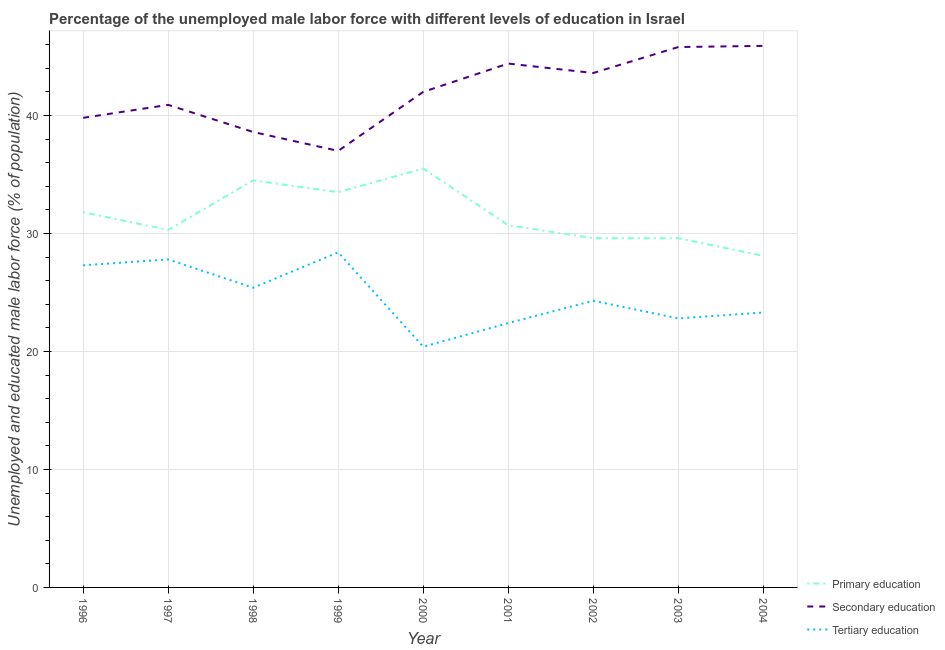How many different coloured lines are there?
Provide a succinct answer. 3. What is the percentage of male labor force who received tertiary education in 2003?
Ensure brevity in your answer.  22.8. Across all years, what is the maximum percentage of male labor force who received primary education?
Ensure brevity in your answer.  35.5. Across all years, what is the minimum percentage of male labor force who received primary education?
Your answer should be compact. 28.1. In which year was the percentage of male labor force who received tertiary education minimum?
Give a very brief answer. 2000. What is the total percentage of male labor force who received secondary education in the graph?
Offer a very short reply. 378. What is the difference between the percentage of male labor force who received secondary education in 1996 and that in 2000?
Your answer should be very brief. -2.2. What is the difference between the percentage of male labor force who received primary education in 2001 and the percentage of male labor force who received secondary education in 2003?
Give a very brief answer. -15.1. What is the average percentage of male labor force who received secondary education per year?
Ensure brevity in your answer.  42. In the year 2003, what is the difference between the percentage of male labor force who received secondary education and percentage of male labor force who received tertiary education?
Provide a short and direct response. 23. What is the ratio of the percentage of male labor force who received tertiary education in 1998 to that in 1999?
Ensure brevity in your answer.  0.89. Is the percentage of male labor force who received tertiary education in 1998 less than that in 2000?
Your response must be concise. No. What is the difference between the highest and the second highest percentage of male labor force who received secondary education?
Your answer should be compact. 0.1. What is the difference between the highest and the lowest percentage of male labor force who received primary education?
Offer a terse response. 7.4. Is the sum of the percentage of male labor force who received primary education in 2000 and 2001 greater than the maximum percentage of male labor force who received tertiary education across all years?
Keep it short and to the point. Yes. Is the percentage of male labor force who received primary education strictly less than the percentage of male labor force who received tertiary education over the years?
Offer a very short reply. No. Are the values on the major ticks of Y-axis written in scientific E-notation?
Provide a short and direct response. No. Does the graph contain any zero values?
Your answer should be very brief. No. Where does the legend appear in the graph?
Your answer should be compact. Bottom right. What is the title of the graph?
Ensure brevity in your answer.  Percentage of the unemployed male labor force with different levels of education in Israel. What is the label or title of the Y-axis?
Give a very brief answer. Unemployed and educated male labor force (% of population). What is the Unemployed and educated male labor force (% of population) in Primary education in 1996?
Your answer should be very brief. 31.8. What is the Unemployed and educated male labor force (% of population) in Secondary education in 1996?
Provide a succinct answer. 39.8. What is the Unemployed and educated male labor force (% of population) in Tertiary education in 1996?
Your answer should be very brief. 27.3. What is the Unemployed and educated male labor force (% of population) in Primary education in 1997?
Provide a short and direct response. 30.3. What is the Unemployed and educated male labor force (% of population) of Secondary education in 1997?
Your answer should be compact. 40.9. What is the Unemployed and educated male labor force (% of population) of Tertiary education in 1997?
Make the answer very short. 27.8. What is the Unemployed and educated male labor force (% of population) of Primary education in 1998?
Keep it short and to the point. 34.5. What is the Unemployed and educated male labor force (% of population) in Secondary education in 1998?
Your answer should be compact. 38.6. What is the Unemployed and educated male labor force (% of population) in Tertiary education in 1998?
Offer a terse response. 25.4. What is the Unemployed and educated male labor force (% of population) of Primary education in 1999?
Ensure brevity in your answer.  33.5. What is the Unemployed and educated male labor force (% of population) of Secondary education in 1999?
Provide a succinct answer. 37. What is the Unemployed and educated male labor force (% of population) in Tertiary education in 1999?
Your response must be concise. 28.4. What is the Unemployed and educated male labor force (% of population) of Primary education in 2000?
Provide a succinct answer. 35.5. What is the Unemployed and educated male labor force (% of population) of Tertiary education in 2000?
Offer a very short reply. 20.4. What is the Unemployed and educated male labor force (% of population) in Primary education in 2001?
Your answer should be very brief. 30.7. What is the Unemployed and educated male labor force (% of population) of Secondary education in 2001?
Offer a terse response. 44.4. What is the Unemployed and educated male labor force (% of population) in Tertiary education in 2001?
Give a very brief answer. 22.4. What is the Unemployed and educated male labor force (% of population) in Primary education in 2002?
Ensure brevity in your answer.  29.6. What is the Unemployed and educated male labor force (% of population) in Secondary education in 2002?
Your response must be concise. 43.6. What is the Unemployed and educated male labor force (% of population) of Tertiary education in 2002?
Ensure brevity in your answer.  24.3. What is the Unemployed and educated male labor force (% of population) in Primary education in 2003?
Keep it short and to the point. 29.6. What is the Unemployed and educated male labor force (% of population) in Secondary education in 2003?
Offer a terse response. 45.8. What is the Unemployed and educated male labor force (% of population) in Tertiary education in 2003?
Provide a short and direct response. 22.8. What is the Unemployed and educated male labor force (% of population) in Primary education in 2004?
Your response must be concise. 28.1. What is the Unemployed and educated male labor force (% of population) of Secondary education in 2004?
Offer a very short reply. 45.9. What is the Unemployed and educated male labor force (% of population) of Tertiary education in 2004?
Offer a terse response. 23.3. Across all years, what is the maximum Unemployed and educated male labor force (% of population) in Primary education?
Keep it short and to the point. 35.5. Across all years, what is the maximum Unemployed and educated male labor force (% of population) of Secondary education?
Ensure brevity in your answer.  45.9. Across all years, what is the maximum Unemployed and educated male labor force (% of population) in Tertiary education?
Offer a terse response. 28.4. Across all years, what is the minimum Unemployed and educated male labor force (% of population) of Primary education?
Offer a very short reply. 28.1. Across all years, what is the minimum Unemployed and educated male labor force (% of population) of Secondary education?
Offer a terse response. 37. Across all years, what is the minimum Unemployed and educated male labor force (% of population) of Tertiary education?
Offer a very short reply. 20.4. What is the total Unemployed and educated male labor force (% of population) of Primary education in the graph?
Offer a very short reply. 283.6. What is the total Unemployed and educated male labor force (% of population) of Secondary education in the graph?
Give a very brief answer. 378. What is the total Unemployed and educated male labor force (% of population) of Tertiary education in the graph?
Provide a short and direct response. 222.1. What is the difference between the Unemployed and educated male labor force (% of population) in Primary education in 1996 and that in 1997?
Ensure brevity in your answer.  1.5. What is the difference between the Unemployed and educated male labor force (% of population) of Tertiary education in 1996 and that in 1997?
Keep it short and to the point. -0.5. What is the difference between the Unemployed and educated male labor force (% of population) in Primary education in 1996 and that in 1998?
Provide a succinct answer. -2.7. What is the difference between the Unemployed and educated male labor force (% of population) in Secondary education in 1996 and that in 1998?
Offer a terse response. 1.2. What is the difference between the Unemployed and educated male labor force (% of population) of Primary education in 1996 and that in 1999?
Give a very brief answer. -1.7. What is the difference between the Unemployed and educated male labor force (% of population) in Secondary education in 1996 and that in 1999?
Provide a short and direct response. 2.8. What is the difference between the Unemployed and educated male labor force (% of population) of Tertiary education in 1996 and that in 1999?
Your answer should be very brief. -1.1. What is the difference between the Unemployed and educated male labor force (% of population) of Secondary education in 1996 and that in 2000?
Make the answer very short. -2.2. What is the difference between the Unemployed and educated male labor force (% of population) of Primary education in 1996 and that in 2001?
Your response must be concise. 1.1. What is the difference between the Unemployed and educated male labor force (% of population) in Secondary education in 1996 and that in 2001?
Give a very brief answer. -4.6. What is the difference between the Unemployed and educated male labor force (% of population) in Tertiary education in 1996 and that in 2001?
Offer a very short reply. 4.9. What is the difference between the Unemployed and educated male labor force (% of population) of Primary education in 1996 and that in 2002?
Make the answer very short. 2.2. What is the difference between the Unemployed and educated male labor force (% of population) in Tertiary education in 1996 and that in 2002?
Make the answer very short. 3. What is the difference between the Unemployed and educated male labor force (% of population) in Primary education in 1996 and that in 2003?
Provide a succinct answer. 2.2. What is the difference between the Unemployed and educated male labor force (% of population) of Secondary education in 1996 and that in 2003?
Provide a short and direct response. -6. What is the difference between the Unemployed and educated male labor force (% of population) in Tertiary education in 1996 and that in 2003?
Your answer should be compact. 4.5. What is the difference between the Unemployed and educated male labor force (% of population) in Primary education in 1997 and that in 1998?
Your response must be concise. -4.2. What is the difference between the Unemployed and educated male labor force (% of population) in Secondary education in 1997 and that in 1998?
Provide a succinct answer. 2.3. What is the difference between the Unemployed and educated male labor force (% of population) of Primary education in 1997 and that in 1999?
Give a very brief answer. -3.2. What is the difference between the Unemployed and educated male labor force (% of population) in Tertiary education in 1997 and that in 1999?
Your response must be concise. -0.6. What is the difference between the Unemployed and educated male labor force (% of population) in Tertiary education in 1997 and that in 2000?
Offer a terse response. 7.4. What is the difference between the Unemployed and educated male labor force (% of population) in Secondary education in 1997 and that in 2001?
Offer a terse response. -3.5. What is the difference between the Unemployed and educated male labor force (% of population) of Secondary education in 1997 and that in 2002?
Ensure brevity in your answer.  -2.7. What is the difference between the Unemployed and educated male labor force (% of population) in Secondary education in 1997 and that in 2003?
Offer a terse response. -4.9. What is the difference between the Unemployed and educated male labor force (% of population) in Tertiary education in 1997 and that in 2003?
Your response must be concise. 5. What is the difference between the Unemployed and educated male labor force (% of population) of Secondary education in 1997 and that in 2004?
Keep it short and to the point. -5. What is the difference between the Unemployed and educated male labor force (% of population) of Tertiary education in 1998 and that in 1999?
Provide a short and direct response. -3. What is the difference between the Unemployed and educated male labor force (% of population) in Secondary education in 1998 and that in 2000?
Your response must be concise. -3.4. What is the difference between the Unemployed and educated male labor force (% of population) of Tertiary education in 1998 and that in 2000?
Ensure brevity in your answer.  5. What is the difference between the Unemployed and educated male labor force (% of population) in Tertiary education in 1998 and that in 2001?
Keep it short and to the point. 3. What is the difference between the Unemployed and educated male labor force (% of population) of Secondary education in 1998 and that in 2002?
Offer a terse response. -5. What is the difference between the Unemployed and educated male labor force (% of population) of Tertiary education in 1998 and that in 2002?
Provide a succinct answer. 1.1. What is the difference between the Unemployed and educated male labor force (% of population) of Tertiary education in 1998 and that in 2003?
Keep it short and to the point. 2.6. What is the difference between the Unemployed and educated male labor force (% of population) of Tertiary education in 1998 and that in 2004?
Your answer should be very brief. 2.1. What is the difference between the Unemployed and educated male labor force (% of population) in Tertiary education in 1999 and that in 2001?
Your answer should be compact. 6. What is the difference between the Unemployed and educated male labor force (% of population) of Secondary education in 1999 and that in 2002?
Your answer should be compact. -6.6. What is the difference between the Unemployed and educated male labor force (% of population) in Tertiary education in 1999 and that in 2002?
Make the answer very short. 4.1. What is the difference between the Unemployed and educated male labor force (% of population) of Primary education in 1999 and that in 2003?
Offer a terse response. 3.9. What is the difference between the Unemployed and educated male labor force (% of population) in Secondary education in 1999 and that in 2003?
Make the answer very short. -8.8. What is the difference between the Unemployed and educated male labor force (% of population) of Primary education in 1999 and that in 2004?
Offer a terse response. 5.4. What is the difference between the Unemployed and educated male labor force (% of population) in Tertiary education in 1999 and that in 2004?
Provide a succinct answer. 5.1. What is the difference between the Unemployed and educated male labor force (% of population) in Tertiary education in 2000 and that in 2001?
Your answer should be compact. -2. What is the difference between the Unemployed and educated male labor force (% of population) in Primary education in 2000 and that in 2002?
Your answer should be very brief. 5.9. What is the difference between the Unemployed and educated male labor force (% of population) in Tertiary education in 2000 and that in 2002?
Your response must be concise. -3.9. What is the difference between the Unemployed and educated male labor force (% of population) of Primary education in 2000 and that in 2003?
Your answer should be very brief. 5.9. What is the difference between the Unemployed and educated male labor force (% of population) of Secondary education in 2000 and that in 2004?
Give a very brief answer. -3.9. What is the difference between the Unemployed and educated male labor force (% of population) in Tertiary education in 2000 and that in 2004?
Your answer should be very brief. -2.9. What is the difference between the Unemployed and educated male labor force (% of population) in Secondary education in 2001 and that in 2002?
Ensure brevity in your answer.  0.8. What is the difference between the Unemployed and educated male labor force (% of population) of Tertiary education in 2001 and that in 2002?
Your response must be concise. -1.9. What is the difference between the Unemployed and educated male labor force (% of population) of Tertiary education in 2001 and that in 2003?
Offer a terse response. -0.4. What is the difference between the Unemployed and educated male labor force (% of population) in Tertiary education in 2001 and that in 2004?
Your answer should be very brief. -0.9. What is the difference between the Unemployed and educated male labor force (% of population) of Primary education in 2002 and that in 2003?
Keep it short and to the point. 0. What is the difference between the Unemployed and educated male labor force (% of population) in Secondary education in 2002 and that in 2003?
Offer a very short reply. -2.2. What is the difference between the Unemployed and educated male labor force (% of population) of Primary education in 2002 and that in 2004?
Offer a very short reply. 1.5. What is the difference between the Unemployed and educated male labor force (% of population) in Secondary education in 2002 and that in 2004?
Your answer should be compact. -2.3. What is the difference between the Unemployed and educated male labor force (% of population) in Primary education in 2003 and that in 2004?
Offer a terse response. 1.5. What is the difference between the Unemployed and educated male labor force (% of population) of Primary education in 1996 and the Unemployed and educated male labor force (% of population) of Tertiary education in 1997?
Offer a very short reply. 4. What is the difference between the Unemployed and educated male labor force (% of population) in Secondary education in 1996 and the Unemployed and educated male labor force (% of population) in Tertiary education in 1997?
Offer a terse response. 12. What is the difference between the Unemployed and educated male labor force (% of population) of Primary education in 1996 and the Unemployed and educated male labor force (% of population) of Secondary education in 1998?
Offer a terse response. -6.8. What is the difference between the Unemployed and educated male labor force (% of population) in Secondary education in 1996 and the Unemployed and educated male labor force (% of population) in Tertiary education in 1998?
Offer a very short reply. 14.4. What is the difference between the Unemployed and educated male labor force (% of population) of Primary education in 1996 and the Unemployed and educated male labor force (% of population) of Tertiary education in 1999?
Give a very brief answer. 3.4. What is the difference between the Unemployed and educated male labor force (% of population) in Secondary education in 1996 and the Unemployed and educated male labor force (% of population) in Tertiary education in 1999?
Provide a succinct answer. 11.4. What is the difference between the Unemployed and educated male labor force (% of population) of Primary education in 1996 and the Unemployed and educated male labor force (% of population) of Secondary education in 2001?
Your response must be concise. -12.6. What is the difference between the Unemployed and educated male labor force (% of population) in Primary education in 1996 and the Unemployed and educated male labor force (% of population) in Tertiary education in 2001?
Give a very brief answer. 9.4. What is the difference between the Unemployed and educated male labor force (% of population) in Secondary education in 1996 and the Unemployed and educated male labor force (% of population) in Tertiary education in 2001?
Offer a terse response. 17.4. What is the difference between the Unemployed and educated male labor force (% of population) in Primary education in 1996 and the Unemployed and educated male labor force (% of population) in Secondary education in 2002?
Your answer should be compact. -11.8. What is the difference between the Unemployed and educated male labor force (% of population) in Secondary education in 1996 and the Unemployed and educated male labor force (% of population) in Tertiary education in 2002?
Make the answer very short. 15.5. What is the difference between the Unemployed and educated male labor force (% of population) in Primary education in 1996 and the Unemployed and educated male labor force (% of population) in Tertiary education in 2003?
Provide a succinct answer. 9. What is the difference between the Unemployed and educated male labor force (% of population) of Primary education in 1996 and the Unemployed and educated male labor force (% of population) of Secondary education in 2004?
Ensure brevity in your answer.  -14.1. What is the difference between the Unemployed and educated male labor force (% of population) of Secondary education in 1996 and the Unemployed and educated male labor force (% of population) of Tertiary education in 2004?
Give a very brief answer. 16.5. What is the difference between the Unemployed and educated male labor force (% of population) in Secondary education in 1997 and the Unemployed and educated male labor force (% of population) in Tertiary education in 1998?
Ensure brevity in your answer.  15.5. What is the difference between the Unemployed and educated male labor force (% of population) of Primary education in 1997 and the Unemployed and educated male labor force (% of population) of Secondary education in 2000?
Your answer should be very brief. -11.7. What is the difference between the Unemployed and educated male labor force (% of population) of Primary education in 1997 and the Unemployed and educated male labor force (% of population) of Tertiary education in 2000?
Offer a terse response. 9.9. What is the difference between the Unemployed and educated male labor force (% of population) in Primary education in 1997 and the Unemployed and educated male labor force (% of population) in Secondary education in 2001?
Your answer should be very brief. -14.1. What is the difference between the Unemployed and educated male labor force (% of population) in Primary education in 1997 and the Unemployed and educated male labor force (% of population) in Tertiary education in 2001?
Provide a succinct answer. 7.9. What is the difference between the Unemployed and educated male labor force (% of population) of Secondary education in 1997 and the Unemployed and educated male labor force (% of population) of Tertiary education in 2001?
Ensure brevity in your answer.  18.5. What is the difference between the Unemployed and educated male labor force (% of population) of Primary education in 1997 and the Unemployed and educated male labor force (% of population) of Secondary education in 2002?
Make the answer very short. -13.3. What is the difference between the Unemployed and educated male labor force (% of population) in Primary education in 1997 and the Unemployed and educated male labor force (% of population) in Secondary education in 2003?
Make the answer very short. -15.5. What is the difference between the Unemployed and educated male labor force (% of population) of Primary education in 1997 and the Unemployed and educated male labor force (% of population) of Tertiary education in 2003?
Give a very brief answer. 7.5. What is the difference between the Unemployed and educated male labor force (% of population) of Primary education in 1997 and the Unemployed and educated male labor force (% of population) of Secondary education in 2004?
Your answer should be compact. -15.6. What is the difference between the Unemployed and educated male labor force (% of population) of Primary education in 1997 and the Unemployed and educated male labor force (% of population) of Tertiary education in 2004?
Your answer should be compact. 7. What is the difference between the Unemployed and educated male labor force (% of population) in Secondary education in 1997 and the Unemployed and educated male labor force (% of population) in Tertiary education in 2004?
Give a very brief answer. 17.6. What is the difference between the Unemployed and educated male labor force (% of population) in Primary education in 1998 and the Unemployed and educated male labor force (% of population) in Secondary education in 1999?
Make the answer very short. -2.5. What is the difference between the Unemployed and educated male labor force (% of population) in Secondary education in 1998 and the Unemployed and educated male labor force (% of population) in Tertiary education in 1999?
Your answer should be compact. 10.2. What is the difference between the Unemployed and educated male labor force (% of population) in Primary education in 1998 and the Unemployed and educated male labor force (% of population) in Secondary education in 2000?
Provide a succinct answer. -7.5. What is the difference between the Unemployed and educated male labor force (% of population) of Secondary education in 1998 and the Unemployed and educated male labor force (% of population) of Tertiary education in 2000?
Offer a terse response. 18.2. What is the difference between the Unemployed and educated male labor force (% of population) of Primary education in 1998 and the Unemployed and educated male labor force (% of population) of Tertiary education in 2001?
Make the answer very short. 12.1. What is the difference between the Unemployed and educated male labor force (% of population) of Secondary education in 1998 and the Unemployed and educated male labor force (% of population) of Tertiary education in 2002?
Your answer should be very brief. 14.3. What is the difference between the Unemployed and educated male labor force (% of population) in Primary education in 1998 and the Unemployed and educated male labor force (% of population) in Tertiary education in 2003?
Provide a short and direct response. 11.7. What is the difference between the Unemployed and educated male labor force (% of population) of Secondary education in 1998 and the Unemployed and educated male labor force (% of population) of Tertiary education in 2003?
Offer a terse response. 15.8. What is the difference between the Unemployed and educated male labor force (% of population) of Primary education in 1998 and the Unemployed and educated male labor force (% of population) of Tertiary education in 2004?
Make the answer very short. 11.2. What is the difference between the Unemployed and educated male labor force (% of population) of Primary education in 1999 and the Unemployed and educated male labor force (% of population) of Secondary education in 2000?
Provide a short and direct response. -8.5. What is the difference between the Unemployed and educated male labor force (% of population) in Secondary education in 1999 and the Unemployed and educated male labor force (% of population) in Tertiary education in 2000?
Your response must be concise. 16.6. What is the difference between the Unemployed and educated male labor force (% of population) in Primary education in 1999 and the Unemployed and educated male labor force (% of population) in Tertiary education in 2001?
Ensure brevity in your answer.  11.1. What is the difference between the Unemployed and educated male labor force (% of population) of Primary education in 1999 and the Unemployed and educated male labor force (% of population) of Secondary education in 2002?
Ensure brevity in your answer.  -10.1. What is the difference between the Unemployed and educated male labor force (% of population) of Primary education in 1999 and the Unemployed and educated male labor force (% of population) of Tertiary education in 2002?
Provide a short and direct response. 9.2. What is the difference between the Unemployed and educated male labor force (% of population) of Secondary education in 1999 and the Unemployed and educated male labor force (% of population) of Tertiary education in 2002?
Your answer should be compact. 12.7. What is the difference between the Unemployed and educated male labor force (% of population) in Secondary education in 1999 and the Unemployed and educated male labor force (% of population) in Tertiary education in 2003?
Your answer should be compact. 14.2. What is the difference between the Unemployed and educated male labor force (% of population) in Primary education in 1999 and the Unemployed and educated male labor force (% of population) in Secondary education in 2004?
Your answer should be compact. -12.4. What is the difference between the Unemployed and educated male labor force (% of population) in Primary education in 1999 and the Unemployed and educated male labor force (% of population) in Tertiary education in 2004?
Provide a succinct answer. 10.2. What is the difference between the Unemployed and educated male labor force (% of population) in Secondary education in 1999 and the Unemployed and educated male labor force (% of population) in Tertiary education in 2004?
Your answer should be very brief. 13.7. What is the difference between the Unemployed and educated male labor force (% of population) in Primary education in 2000 and the Unemployed and educated male labor force (% of population) in Secondary education in 2001?
Offer a terse response. -8.9. What is the difference between the Unemployed and educated male labor force (% of population) in Primary education in 2000 and the Unemployed and educated male labor force (% of population) in Tertiary education in 2001?
Give a very brief answer. 13.1. What is the difference between the Unemployed and educated male labor force (% of population) in Secondary education in 2000 and the Unemployed and educated male labor force (% of population) in Tertiary education in 2001?
Ensure brevity in your answer.  19.6. What is the difference between the Unemployed and educated male labor force (% of population) of Primary education in 2000 and the Unemployed and educated male labor force (% of population) of Tertiary education in 2002?
Keep it short and to the point. 11.2. What is the difference between the Unemployed and educated male labor force (% of population) in Secondary education in 2000 and the Unemployed and educated male labor force (% of population) in Tertiary education in 2002?
Give a very brief answer. 17.7. What is the difference between the Unemployed and educated male labor force (% of population) in Primary education in 2000 and the Unemployed and educated male labor force (% of population) in Secondary education in 2003?
Offer a terse response. -10.3. What is the difference between the Unemployed and educated male labor force (% of population) of Primary education in 2000 and the Unemployed and educated male labor force (% of population) of Tertiary education in 2004?
Your answer should be very brief. 12.2. What is the difference between the Unemployed and educated male labor force (% of population) of Secondary education in 2000 and the Unemployed and educated male labor force (% of population) of Tertiary education in 2004?
Provide a short and direct response. 18.7. What is the difference between the Unemployed and educated male labor force (% of population) in Primary education in 2001 and the Unemployed and educated male labor force (% of population) in Tertiary education in 2002?
Offer a very short reply. 6.4. What is the difference between the Unemployed and educated male labor force (% of population) of Secondary education in 2001 and the Unemployed and educated male labor force (% of population) of Tertiary education in 2002?
Your answer should be compact. 20.1. What is the difference between the Unemployed and educated male labor force (% of population) of Primary education in 2001 and the Unemployed and educated male labor force (% of population) of Secondary education in 2003?
Your answer should be compact. -15.1. What is the difference between the Unemployed and educated male labor force (% of population) of Secondary education in 2001 and the Unemployed and educated male labor force (% of population) of Tertiary education in 2003?
Make the answer very short. 21.6. What is the difference between the Unemployed and educated male labor force (% of population) of Primary education in 2001 and the Unemployed and educated male labor force (% of population) of Secondary education in 2004?
Provide a succinct answer. -15.2. What is the difference between the Unemployed and educated male labor force (% of population) of Secondary education in 2001 and the Unemployed and educated male labor force (% of population) of Tertiary education in 2004?
Provide a short and direct response. 21.1. What is the difference between the Unemployed and educated male labor force (% of population) in Primary education in 2002 and the Unemployed and educated male labor force (% of population) in Secondary education in 2003?
Your answer should be very brief. -16.2. What is the difference between the Unemployed and educated male labor force (% of population) of Secondary education in 2002 and the Unemployed and educated male labor force (% of population) of Tertiary education in 2003?
Your answer should be compact. 20.8. What is the difference between the Unemployed and educated male labor force (% of population) in Primary education in 2002 and the Unemployed and educated male labor force (% of population) in Secondary education in 2004?
Offer a terse response. -16.3. What is the difference between the Unemployed and educated male labor force (% of population) of Secondary education in 2002 and the Unemployed and educated male labor force (% of population) of Tertiary education in 2004?
Offer a terse response. 20.3. What is the difference between the Unemployed and educated male labor force (% of population) in Primary education in 2003 and the Unemployed and educated male labor force (% of population) in Secondary education in 2004?
Offer a terse response. -16.3. What is the difference between the Unemployed and educated male labor force (% of population) of Primary education in 2003 and the Unemployed and educated male labor force (% of population) of Tertiary education in 2004?
Provide a succinct answer. 6.3. What is the average Unemployed and educated male labor force (% of population) in Primary education per year?
Your answer should be compact. 31.51. What is the average Unemployed and educated male labor force (% of population) of Secondary education per year?
Offer a terse response. 42. What is the average Unemployed and educated male labor force (% of population) in Tertiary education per year?
Give a very brief answer. 24.68. In the year 1996, what is the difference between the Unemployed and educated male labor force (% of population) of Primary education and Unemployed and educated male labor force (% of population) of Secondary education?
Keep it short and to the point. -8. In the year 1996, what is the difference between the Unemployed and educated male labor force (% of population) in Secondary education and Unemployed and educated male labor force (% of population) in Tertiary education?
Your response must be concise. 12.5. In the year 1997, what is the difference between the Unemployed and educated male labor force (% of population) in Primary education and Unemployed and educated male labor force (% of population) in Tertiary education?
Ensure brevity in your answer.  2.5. In the year 1997, what is the difference between the Unemployed and educated male labor force (% of population) of Secondary education and Unemployed and educated male labor force (% of population) of Tertiary education?
Provide a succinct answer. 13.1. In the year 1998, what is the difference between the Unemployed and educated male labor force (% of population) of Secondary education and Unemployed and educated male labor force (% of population) of Tertiary education?
Provide a short and direct response. 13.2. In the year 1999, what is the difference between the Unemployed and educated male labor force (% of population) of Primary education and Unemployed and educated male labor force (% of population) of Secondary education?
Ensure brevity in your answer.  -3.5. In the year 1999, what is the difference between the Unemployed and educated male labor force (% of population) of Primary education and Unemployed and educated male labor force (% of population) of Tertiary education?
Offer a very short reply. 5.1. In the year 1999, what is the difference between the Unemployed and educated male labor force (% of population) of Secondary education and Unemployed and educated male labor force (% of population) of Tertiary education?
Make the answer very short. 8.6. In the year 2000, what is the difference between the Unemployed and educated male labor force (% of population) of Secondary education and Unemployed and educated male labor force (% of population) of Tertiary education?
Provide a short and direct response. 21.6. In the year 2001, what is the difference between the Unemployed and educated male labor force (% of population) in Primary education and Unemployed and educated male labor force (% of population) in Secondary education?
Keep it short and to the point. -13.7. In the year 2002, what is the difference between the Unemployed and educated male labor force (% of population) in Primary education and Unemployed and educated male labor force (% of population) in Tertiary education?
Your response must be concise. 5.3. In the year 2002, what is the difference between the Unemployed and educated male labor force (% of population) of Secondary education and Unemployed and educated male labor force (% of population) of Tertiary education?
Keep it short and to the point. 19.3. In the year 2003, what is the difference between the Unemployed and educated male labor force (% of population) in Primary education and Unemployed and educated male labor force (% of population) in Secondary education?
Give a very brief answer. -16.2. In the year 2003, what is the difference between the Unemployed and educated male labor force (% of population) of Secondary education and Unemployed and educated male labor force (% of population) of Tertiary education?
Your answer should be compact. 23. In the year 2004, what is the difference between the Unemployed and educated male labor force (% of population) in Primary education and Unemployed and educated male labor force (% of population) in Secondary education?
Keep it short and to the point. -17.8. In the year 2004, what is the difference between the Unemployed and educated male labor force (% of population) of Secondary education and Unemployed and educated male labor force (% of population) of Tertiary education?
Your response must be concise. 22.6. What is the ratio of the Unemployed and educated male labor force (% of population) in Primary education in 1996 to that in 1997?
Your answer should be compact. 1.05. What is the ratio of the Unemployed and educated male labor force (% of population) in Secondary education in 1996 to that in 1997?
Offer a very short reply. 0.97. What is the ratio of the Unemployed and educated male labor force (% of population) of Primary education in 1996 to that in 1998?
Keep it short and to the point. 0.92. What is the ratio of the Unemployed and educated male labor force (% of population) of Secondary education in 1996 to that in 1998?
Ensure brevity in your answer.  1.03. What is the ratio of the Unemployed and educated male labor force (% of population) of Tertiary education in 1996 to that in 1998?
Provide a short and direct response. 1.07. What is the ratio of the Unemployed and educated male labor force (% of population) of Primary education in 1996 to that in 1999?
Keep it short and to the point. 0.95. What is the ratio of the Unemployed and educated male labor force (% of population) of Secondary education in 1996 to that in 1999?
Provide a succinct answer. 1.08. What is the ratio of the Unemployed and educated male labor force (% of population) in Tertiary education in 1996 to that in 1999?
Keep it short and to the point. 0.96. What is the ratio of the Unemployed and educated male labor force (% of population) of Primary education in 1996 to that in 2000?
Make the answer very short. 0.9. What is the ratio of the Unemployed and educated male labor force (% of population) in Secondary education in 1996 to that in 2000?
Your answer should be very brief. 0.95. What is the ratio of the Unemployed and educated male labor force (% of population) of Tertiary education in 1996 to that in 2000?
Provide a short and direct response. 1.34. What is the ratio of the Unemployed and educated male labor force (% of population) in Primary education in 1996 to that in 2001?
Provide a short and direct response. 1.04. What is the ratio of the Unemployed and educated male labor force (% of population) in Secondary education in 1996 to that in 2001?
Ensure brevity in your answer.  0.9. What is the ratio of the Unemployed and educated male labor force (% of population) of Tertiary education in 1996 to that in 2001?
Offer a terse response. 1.22. What is the ratio of the Unemployed and educated male labor force (% of population) in Primary education in 1996 to that in 2002?
Offer a terse response. 1.07. What is the ratio of the Unemployed and educated male labor force (% of population) in Secondary education in 1996 to that in 2002?
Offer a very short reply. 0.91. What is the ratio of the Unemployed and educated male labor force (% of population) of Tertiary education in 1996 to that in 2002?
Provide a short and direct response. 1.12. What is the ratio of the Unemployed and educated male labor force (% of population) in Primary education in 1996 to that in 2003?
Your answer should be compact. 1.07. What is the ratio of the Unemployed and educated male labor force (% of population) of Secondary education in 1996 to that in 2003?
Provide a short and direct response. 0.87. What is the ratio of the Unemployed and educated male labor force (% of population) in Tertiary education in 1996 to that in 2003?
Offer a terse response. 1.2. What is the ratio of the Unemployed and educated male labor force (% of population) in Primary education in 1996 to that in 2004?
Keep it short and to the point. 1.13. What is the ratio of the Unemployed and educated male labor force (% of population) in Secondary education in 1996 to that in 2004?
Your answer should be compact. 0.87. What is the ratio of the Unemployed and educated male labor force (% of population) in Tertiary education in 1996 to that in 2004?
Your response must be concise. 1.17. What is the ratio of the Unemployed and educated male labor force (% of population) of Primary education in 1997 to that in 1998?
Make the answer very short. 0.88. What is the ratio of the Unemployed and educated male labor force (% of population) in Secondary education in 1997 to that in 1998?
Make the answer very short. 1.06. What is the ratio of the Unemployed and educated male labor force (% of population) of Tertiary education in 1997 to that in 1998?
Make the answer very short. 1.09. What is the ratio of the Unemployed and educated male labor force (% of population) of Primary education in 1997 to that in 1999?
Provide a succinct answer. 0.9. What is the ratio of the Unemployed and educated male labor force (% of population) in Secondary education in 1997 to that in 1999?
Your response must be concise. 1.11. What is the ratio of the Unemployed and educated male labor force (% of population) in Tertiary education in 1997 to that in 1999?
Your answer should be very brief. 0.98. What is the ratio of the Unemployed and educated male labor force (% of population) in Primary education in 1997 to that in 2000?
Provide a succinct answer. 0.85. What is the ratio of the Unemployed and educated male labor force (% of population) of Secondary education in 1997 to that in 2000?
Ensure brevity in your answer.  0.97. What is the ratio of the Unemployed and educated male labor force (% of population) of Tertiary education in 1997 to that in 2000?
Make the answer very short. 1.36. What is the ratio of the Unemployed and educated male labor force (% of population) of Primary education in 1997 to that in 2001?
Keep it short and to the point. 0.99. What is the ratio of the Unemployed and educated male labor force (% of population) in Secondary education in 1997 to that in 2001?
Provide a succinct answer. 0.92. What is the ratio of the Unemployed and educated male labor force (% of population) in Tertiary education in 1997 to that in 2001?
Your answer should be compact. 1.24. What is the ratio of the Unemployed and educated male labor force (% of population) of Primary education in 1997 to that in 2002?
Your response must be concise. 1.02. What is the ratio of the Unemployed and educated male labor force (% of population) in Secondary education in 1997 to that in 2002?
Offer a terse response. 0.94. What is the ratio of the Unemployed and educated male labor force (% of population) of Tertiary education in 1997 to that in 2002?
Ensure brevity in your answer.  1.14. What is the ratio of the Unemployed and educated male labor force (% of population) of Primary education in 1997 to that in 2003?
Keep it short and to the point. 1.02. What is the ratio of the Unemployed and educated male labor force (% of population) of Secondary education in 1997 to that in 2003?
Your answer should be compact. 0.89. What is the ratio of the Unemployed and educated male labor force (% of population) in Tertiary education in 1997 to that in 2003?
Make the answer very short. 1.22. What is the ratio of the Unemployed and educated male labor force (% of population) in Primary education in 1997 to that in 2004?
Your response must be concise. 1.08. What is the ratio of the Unemployed and educated male labor force (% of population) in Secondary education in 1997 to that in 2004?
Ensure brevity in your answer.  0.89. What is the ratio of the Unemployed and educated male labor force (% of population) of Tertiary education in 1997 to that in 2004?
Provide a short and direct response. 1.19. What is the ratio of the Unemployed and educated male labor force (% of population) of Primary education in 1998 to that in 1999?
Your answer should be compact. 1.03. What is the ratio of the Unemployed and educated male labor force (% of population) of Secondary education in 1998 to that in 1999?
Your answer should be compact. 1.04. What is the ratio of the Unemployed and educated male labor force (% of population) of Tertiary education in 1998 to that in 1999?
Your response must be concise. 0.89. What is the ratio of the Unemployed and educated male labor force (% of population) in Primary education in 1998 to that in 2000?
Provide a short and direct response. 0.97. What is the ratio of the Unemployed and educated male labor force (% of population) of Secondary education in 1998 to that in 2000?
Keep it short and to the point. 0.92. What is the ratio of the Unemployed and educated male labor force (% of population) of Tertiary education in 1998 to that in 2000?
Offer a terse response. 1.25. What is the ratio of the Unemployed and educated male labor force (% of population) of Primary education in 1998 to that in 2001?
Give a very brief answer. 1.12. What is the ratio of the Unemployed and educated male labor force (% of population) of Secondary education in 1998 to that in 2001?
Offer a very short reply. 0.87. What is the ratio of the Unemployed and educated male labor force (% of population) in Tertiary education in 1998 to that in 2001?
Keep it short and to the point. 1.13. What is the ratio of the Unemployed and educated male labor force (% of population) in Primary education in 1998 to that in 2002?
Keep it short and to the point. 1.17. What is the ratio of the Unemployed and educated male labor force (% of population) in Secondary education in 1998 to that in 2002?
Offer a terse response. 0.89. What is the ratio of the Unemployed and educated male labor force (% of population) in Tertiary education in 1998 to that in 2002?
Your answer should be very brief. 1.05. What is the ratio of the Unemployed and educated male labor force (% of population) in Primary education in 1998 to that in 2003?
Make the answer very short. 1.17. What is the ratio of the Unemployed and educated male labor force (% of population) of Secondary education in 1998 to that in 2003?
Ensure brevity in your answer.  0.84. What is the ratio of the Unemployed and educated male labor force (% of population) in Tertiary education in 1998 to that in 2003?
Keep it short and to the point. 1.11. What is the ratio of the Unemployed and educated male labor force (% of population) of Primary education in 1998 to that in 2004?
Your answer should be very brief. 1.23. What is the ratio of the Unemployed and educated male labor force (% of population) in Secondary education in 1998 to that in 2004?
Make the answer very short. 0.84. What is the ratio of the Unemployed and educated male labor force (% of population) in Tertiary education in 1998 to that in 2004?
Keep it short and to the point. 1.09. What is the ratio of the Unemployed and educated male labor force (% of population) of Primary education in 1999 to that in 2000?
Offer a very short reply. 0.94. What is the ratio of the Unemployed and educated male labor force (% of population) in Secondary education in 1999 to that in 2000?
Provide a short and direct response. 0.88. What is the ratio of the Unemployed and educated male labor force (% of population) in Tertiary education in 1999 to that in 2000?
Offer a very short reply. 1.39. What is the ratio of the Unemployed and educated male labor force (% of population) of Primary education in 1999 to that in 2001?
Your answer should be compact. 1.09. What is the ratio of the Unemployed and educated male labor force (% of population) of Secondary education in 1999 to that in 2001?
Your answer should be compact. 0.83. What is the ratio of the Unemployed and educated male labor force (% of population) of Tertiary education in 1999 to that in 2001?
Your answer should be compact. 1.27. What is the ratio of the Unemployed and educated male labor force (% of population) of Primary education in 1999 to that in 2002?
Provide a short and direct response. 1.13. What is the ratio of the Unemployed and educated male labor force (% of population) of Secondary education in 1999 to that in 2002?
Provide a short and direct response. 0.85. What is the ratio of the Unemployed and educated male labor force (% of population) of Tertiary education in 1999 to that in 2002?
Give a very brief answer. 1.17. What is the ratio of the Unemployed and educated male labor force (% of population) in Primary education in 1999 to that in 2003?
Your answer should be compact. 1.13. What is the ratio of the Unemployed and educated male labor force (% of population) in Secondary education in 1999 to that in 2003?
Offer a terse response. 0.81. What is the ratio of the Unemployed and educated male labor force (% of population) of Tertiary education in 1999 to that in 2003?
Offer a very short reply. 1.25. What is the ratio of the Unemployed and educated male labor force (% of population) in Primary education in 1999 to that in 2004?
Ensure brevity in your answer.  1.19. What is the ratio of the Unemployed and educated male labor force (% of population) of Secondary education in 1999 to that in 2004?
Give a very brief answer. 0.81. What is the ratio of the Unemployed and educated male labor force (% of population) of Tertiary education in 1999 to that in 2004?
Keep it short and to the point. 1.22. What is the ratio of the Unemployed and educated male labor force (% of population) of Primary education in 2000 to that in 2001?
Make the answer very short. 1.16. What is the ratio of the Unemployed and educated male labor force (% of population) in Secondary education in 2000 to that in 2001?
Offer a very short reply. 0.95. What is the ratio of the Unemployed and educated male labor force (% of population) of Tertiary education in 2000 to that in 2001?
Provide a succinct answer. 0.91. What is the ratio of the Unemployed and educated male labor force (% of population) of Primary education in 2000 to that in 2002?
Ensure brevity in your answer.  1.2. What is the ratio of the Unemployed and educated male labor force (% of population) in Secondary education in 2000 to that in 2002?
Ensure brevity in your answer.  0.96. What is the ratio of the Unemployed and educated male labor force (% of population) of Tertiary education in 2000 to that in 2002?
Offer a terse response. 0.84. What is the ratio of the Unemployed and educated male labor force (% of population) in Primary education in 2000 to that in 2003?
Offer a terse response. 1.2. What is the ratio of the Unemployed and educated male labor force (% of population) in Secondary education in 2000 to that in 2003?
Offer a very short reply. 0.92. What is the ratio of the Unemployed and educated male labor force (% of population) of Tertiary education in 2000 to that in 2003?
Offer a very short reply. 0.89. What is the ratio of the Unemployed and educated male labor force (% of population) in Primary education in 2000 to that in 2004?
Provide a succinct answer. 1.26. What is the ratio of the Unemployed and educated male labor force (% of population) of Secondary education in 2000 to that in 2004?
Offer a very short reply. 0.92. What is the ratio of the Unemployed and educated male labor force (% of population) in Tertiary education in 2000 to that in 2004?
Offer a terse response. 0.88. What is the ratio of the Unemployed and educated male labor force (% of population) of Primary education in 2001 to that in 2002?
Provide a short and direct response. 1.04. What is the ratio of the Unemployed and educated male labor force (% of population) of Secondary education in 2001 to that in 2002?
Keep it short and to the point. 1.02. What is the ratio of the Unemployed and educated male labor force (% of population) of Tertiary education in 2001 to that in 2002?
Offer a very short reply. 0.92. What is the ratio of the Unemployed and educated male labor force (% of population) of Primary education in 2001 to that in 2003?
Give a very brief answer. 1.04. What is the ratio of the Unemployed and educated male labor force (% of population) of Secondary education in 2001 to that in 2003?
Offer a very short reply. 0.97. What is the ratio of the Unemployed and educated male labor force (% of population) in Tertiary education in 2001 to that in 2003?
Offer a terse response. 0.98. What is the ratio of the Unemployed and educated male labor force (% of population) of Primary education in 2001 to that in 2004?
Ensure brevity in your answer.  1.09. What is the ratio of the Unemployed and educated male labor force (% of population) in Secondary education in 2001 to that in 2004?
Provide a succinct answer. 0.97. What is the ratio of the Unemployed and educated male labor force (% of population) of Tertiary education in 2001 to that in 2004?
Offer a terse response. 0.96. What is the ratio of the Unemployed and educated male labor force (% of population) in Secondary education in 2002 to that in 2003?
Your answer should be very brief. 0.95. What is the ratio of the Unemployed and educated male labor force (% of population) in Tertiary education in 2002 to that in 2003?
Make the answer very short. 1.07. What is the ratio of the Unemployed and educated male labor force (% of population) in Primary education in 2002 to that in 2004?
Keep it short and to the point. 1.05. What is the ratio of the Unemployed and educated male labor force (% of population) of Secondary education in 2002 to that in 2004?
Provide a short and direct response. 0.95. What is the ratio of the Unemployed and educated male labor force (% of population) of Tertiary education in 2002 to that in 2004?
Ensure brevity in your answer.  1.04. What is the ratio of the Unemployed and educated male labor force (% of population) of Primary education in 2003 to that in 2004?
Your answer should be very brief. 1.05. What is the ratio of the Unemployed and educated male labor force (% of population) of Tertiary education in 2003 to that in 2004?
Your answer should be very brief. 0.98. What is the difference between the highest and the second highest Unemployed and educated male labor force (% of population) in Secondary education?
Your answer should be compact. 0.1. What is the difference between the highest and the second highest Unemployed and educated male labor force (% of population) of Tertiary education?
Your response must be concise. 0.6. 